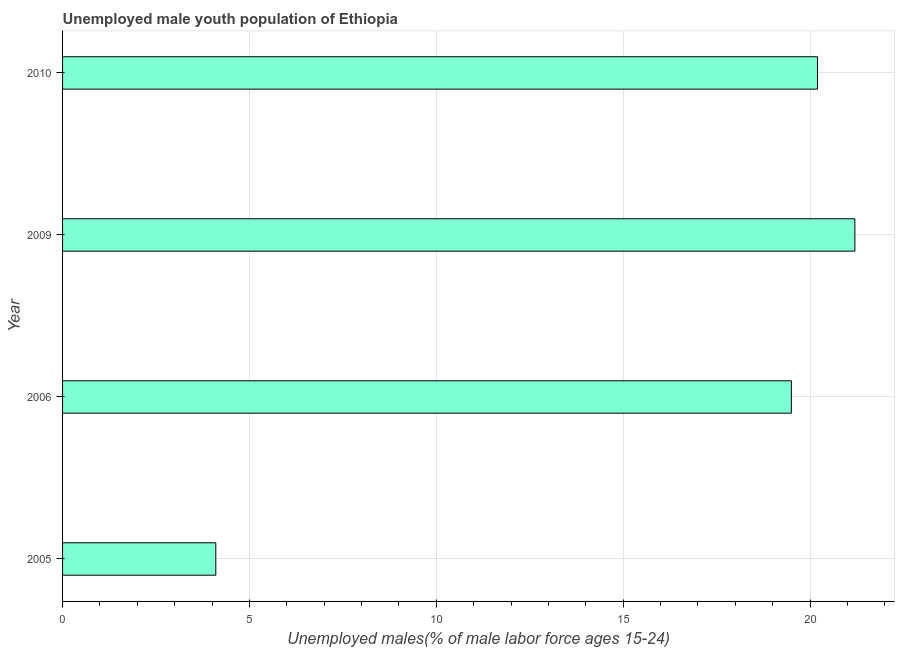Does the graph contain any zero values?
Make the answer very short. No. Does the graph contain grids?
Provide a short and direct response. Yes. What is the title of the graph?
Your answer should be compact. Unemployed male youth population of Ethiopia. What is the label or title of the X-axis?
Provide a succinct answer. Unemployed males(% of male labor force ages 15-24). What is the unemployed male youth in 2006?
Offer a terse response. 19.5. Across all years, what is the maximum unemployed male youth?
Offer a terse response. 21.2. Across all years, what is the minimum unemployed male youth?
Provide a short and direct response. 4.1. In which year was the unemployed male youth maximum?
Provide a succinct answer. 2009. In which year was the unemployed male youth minimum?
Ensure brevity in your answer.  2005. What is the sum of the unemployed male youth?
Give a very brief answer. 65. What is the difference between the unemployed male youth in 2005 and 2010?
Provide a short and direct response. -16.1. What is the average unemployed male youth per year?
Give a very brief answer. 16.25. What is the median unemployed male youth?
Keep it short and to the point. 19.85. Do a majority of the years between 2009 and 2010 (inclusive) have unemployed male youth greater than 20 %?
Give a very brief answer. Yes. What is the ratio of the unemployed male youth in 2005 to that in 2006?
Offer a very short reply. 0.21. Is the sum of the unemployed male youth in 2005 and 2006 greater than the maximum unemployed male youth across all years?
Offer a very short reply. Yes. What is the difference between the highest and the lowest unemployed male youth?
Your answer should be compact. 17.1. In how many years, is the unemployed male youth greater than the average unemployed male youth taken over all years?
Your answer should be compact. 3. How many bars are there?
Your answer should be very brief. 4. How many years are there in the graph?
Your answer should be compact. 4. Are the values on the major ticks of X-axis written in scientific E-notation?
Make the answer very short. No. What is the Unemployed males(% of male labor force ages 15-24) in 2005?
Give a very brief answer. 4.1. What is the Unemployed males(% of male labor force ages 15-24) of 2009?
Provide a short and direct response. 21.2. What is the Unemployed males(% of male labor force ages 15-24) in 2010?
Your answer should be very brief. 20.2. What is the difference between the Unemployed males(% of male labor force ages 15-24) in 2005 and 2006?
Make the answer very short. -15.4. What is the difference between the Unemployed males(% of male labor force ages 15-24) in 2005 and 2009?
Provide a succinct answer. -17.1. What is the difference between the Unemployed males(% of male labor force ages 15-24) in 2005 and 2010?
Your response must be concise. -16.1. What is the difference between the Unemployed males(% of male labor force ages 15-24) in 2006 and 2010?
Your answer should be very brief. -0.7. What is the difference between the Unemployed males(% of male labor force ages 15-24) in 2009 and 2010?
Your answer should be very brief. 1. What is the ratio of the Unemployed males(% of male labor force ages 15-24) in 2005 to that in 2006?
Provide a succinct answer. 0.21. What is the ratio of the Unemployed males(% of male labor force ages 15-24) in 2005 to that in 2009?
Your answer should be compact. 0.19. What is the ratio of the Unemployed males(% of male labor force ages 15-24) in 2005 to that in 2010?
Ensure brevity in your answer.  0.2. What is the ratio of the Unemployed males(% of male labor force ages 15-24) in 2006 to that in 2010?
Make the answer very short. 0.96. 